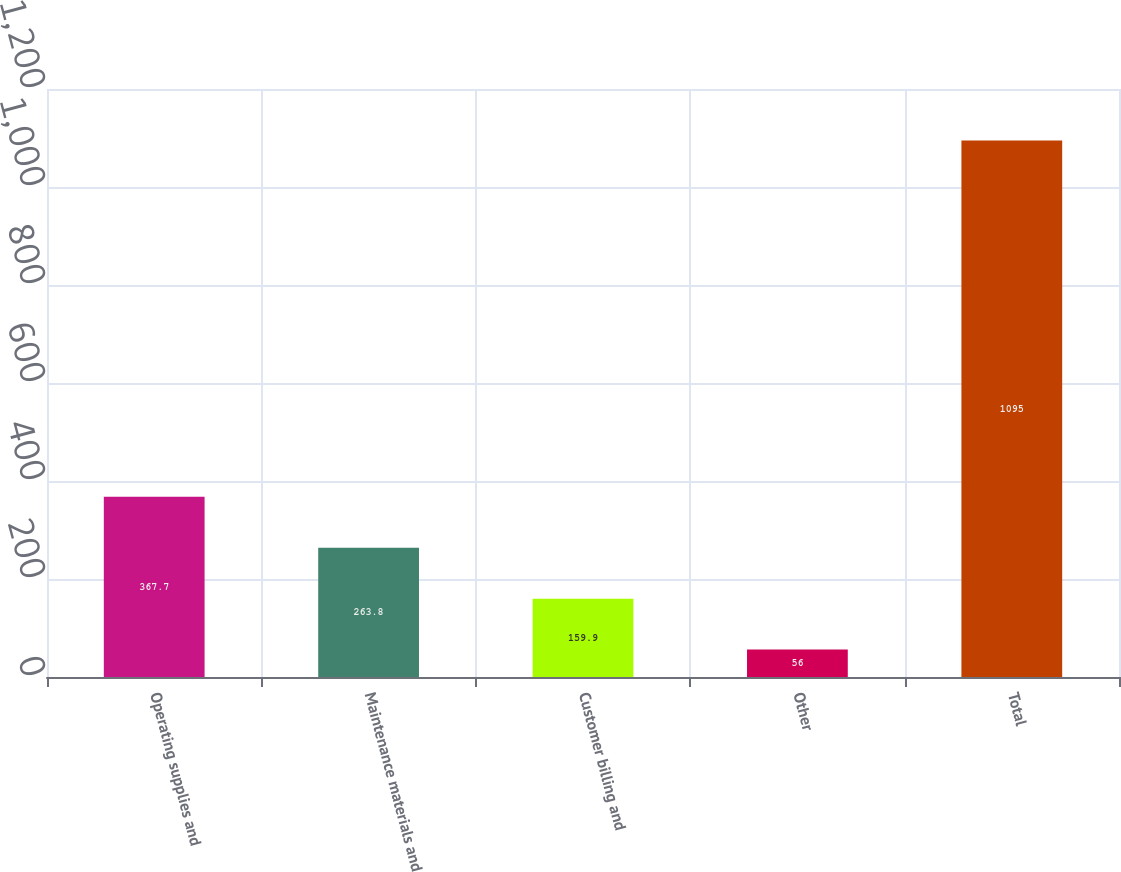Convert chart. <chart><loc_0><loc_0><loc_500><loc_500><bar_chart><fcel>Operating supplies and<fcel>Maintenance materials and<fcel>Customer billing and<fcel>Other<fcel>Total<nl><fcel>367.7<fcel>263.8<fcel>159.9<fcel>56<fcel>1095<nl></chart> 